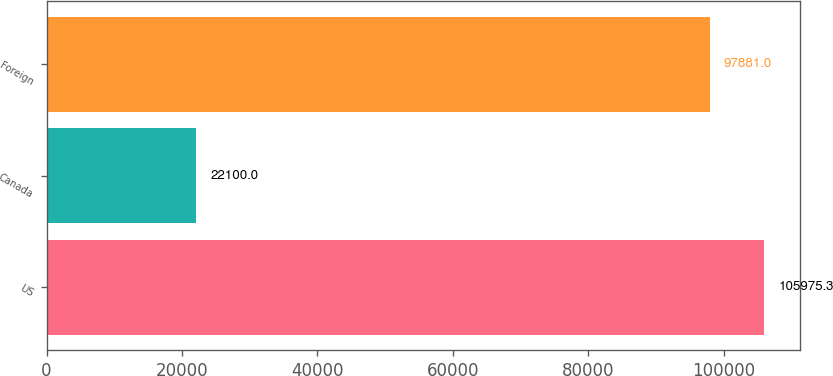<chart> <loc_0><loc_0><loc_500><loc_500><bar_chart><fcel>US<fcel>Canada<fcel>Foreign<nl><fcel>105975<fcel>22100<fcel>97881<nl></chart> 